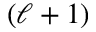Convert formula to latex. <formula><loc_0><loc_0><loc_500><loc_500>( \ell + 1 )</formula> 